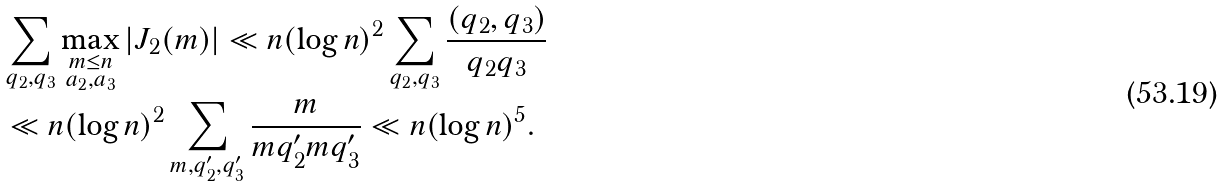Convert formula to latex. <formula><loc_0><loc_0><loc_500><loc_500>& \sum _ { q _ { 2 } , q _ { 3 } } \max _ { \substack { m \leq n \\ a _ { 2 } , a _ { 3 } } } | J _ { 2 } ( m ) | \ll n ( \log n ) ^ { 2 } \sum _ { q _ { 2 } , q _ { 3 } } \frac { ( q _ { 2 } , q _ { 3 } ) } { q _ { 2 } q _ { 3 } } \\ & \ll n ( \log n ) ^ { 2 } \sum _ { m , q _ { 2 } ^ { \prime } , q _ { 3 } ^ { \prime } } \frac { m } { m q _ { 2 } ^ { \prime } m q _ { 3 } ^ { \prime } } \ll n ( \log n ) ^ { 5 } .</formula> 